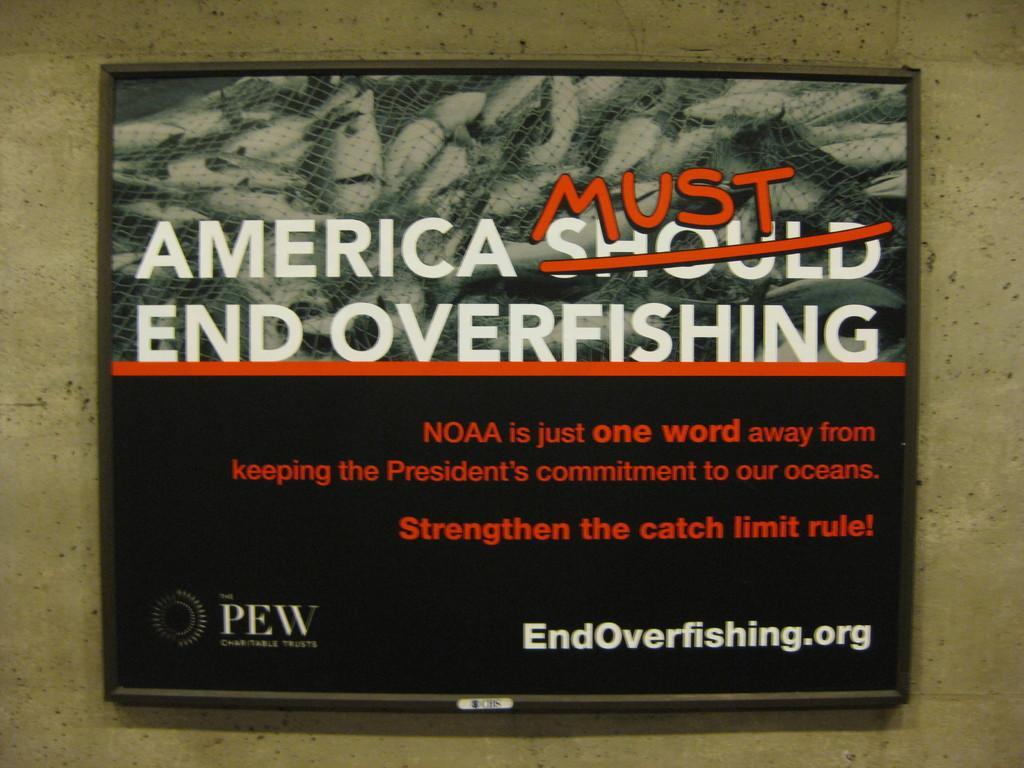Provide a one-sentence caption for the provided image. Sign on a wall that says "America Must end Overfishing". 